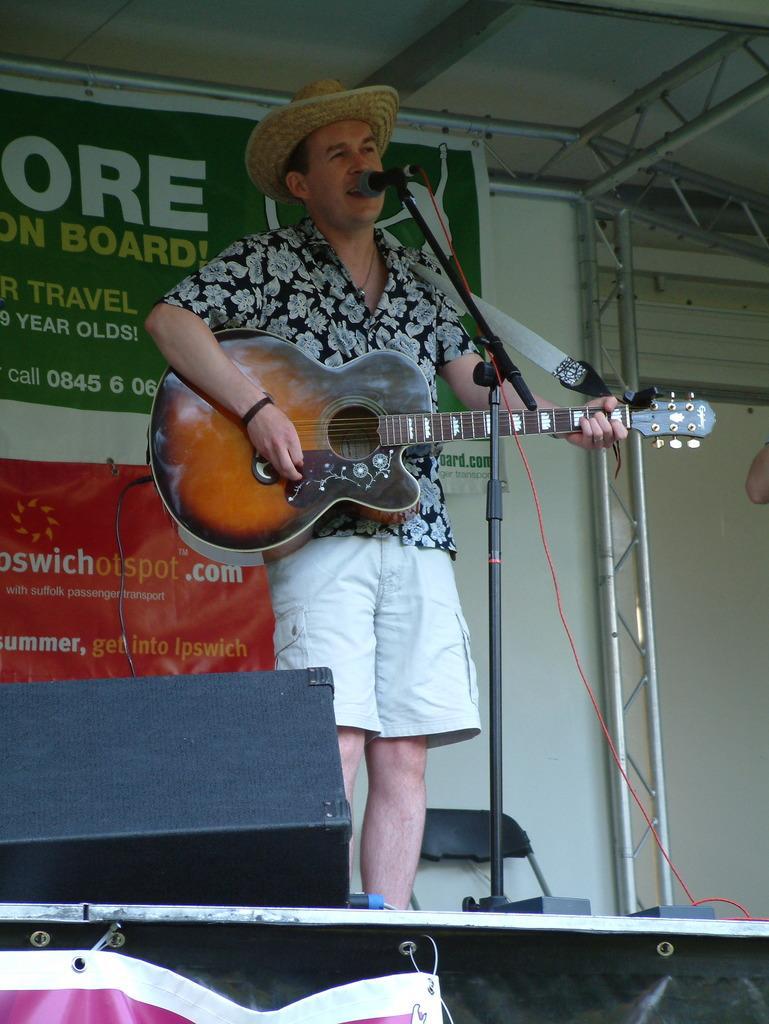Please provide a concise description of this image. In the picture there is a man standing and singing. He is playing guitar. In front of him there is microphone and its stand. On the dais there is a chair and a speaker. In the background there is wall and posters are sticked on it.  